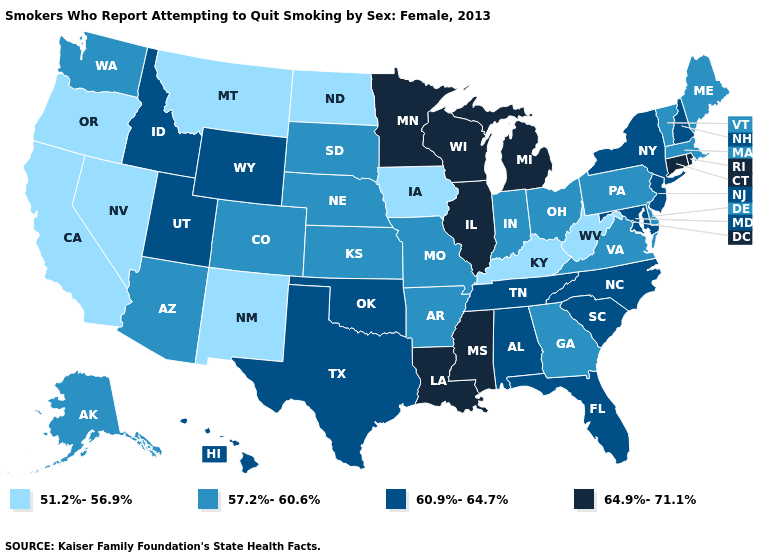What is the lowest value in states that border Illinois?
Give a very brief answer. 51.2%-56.9%. Name the states that have a value in the range 51.2%-56.9%?
Keep it brief. California, Iowa, Kentucky, Montana, Nevada, New Mexico, North Dakota, Oregon, West Virginia. What is the value of Wyoming?
Write a very short answer. 60.9%-64.7%. Among the states that border Idaho , which have the highest value?
Answer briefly. Utah, Wyoming. What is the highest value in the South ?
Give a very brief answer. 64.9%-71.1%. What is the lowest value in the USA?
Answer briefly. 51.2%-56.9%. What is the highest value in the Northeast ?
Short answer required. 64.9%-71.1%. Which states have the highest value in the USA?
Give a very brief answer. Connecticut, Illinois, Louisiana, Michigan, Minnesota, Mississippi, Rhode Island, Wisconsin. What is the value of Louisiana?
Give a very brief answer. 64.9%-71.1%. Name the states that have a value in the range 57.2%-60.6%?
Answer briefly. Alaska, Arizona, Arkansas, Colorado, Delaware, Georgia, Indiana, Kansas, Maine, Massachusetts, Missouri, Nebraska, Ohio, Pennsylvania, South Dakota, Vermont, Virginia, Washington. Does Ohio have a higher value than California?
Be succinct. Yes. Does the first symbol in the legend represent the smallest category?
Be succinct. Yes. Does Kentucky have the lowest value in the South?
Be succinct. Yes. What is the value of Illinois?
Keep it brief. 64.9%-71.1%. 